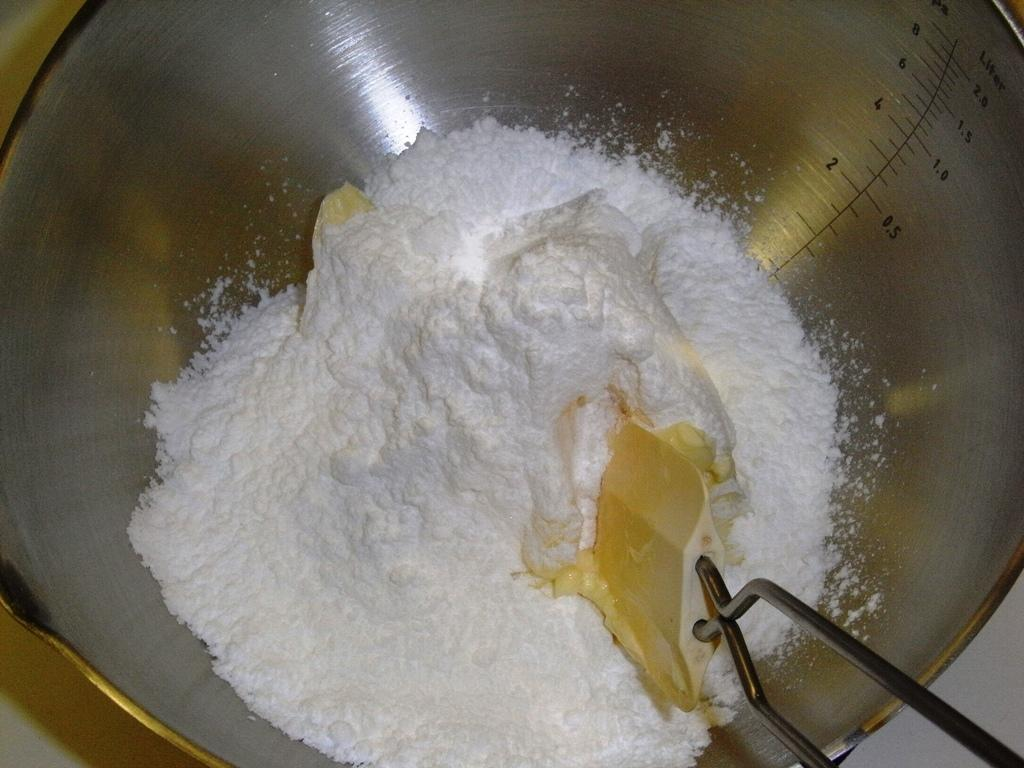What is inside the steel container in the image? There is flour in a steel container in the image. What is being used in the bowl in the image? There is a whisk in a bowl in the image. What type of protest is happening in the image? There is no protest present in the image; it only shows a steel container with flour and a bowl with a whisk. How many ladybugs can be seen in the image? There are no ladybugs present in the image. 